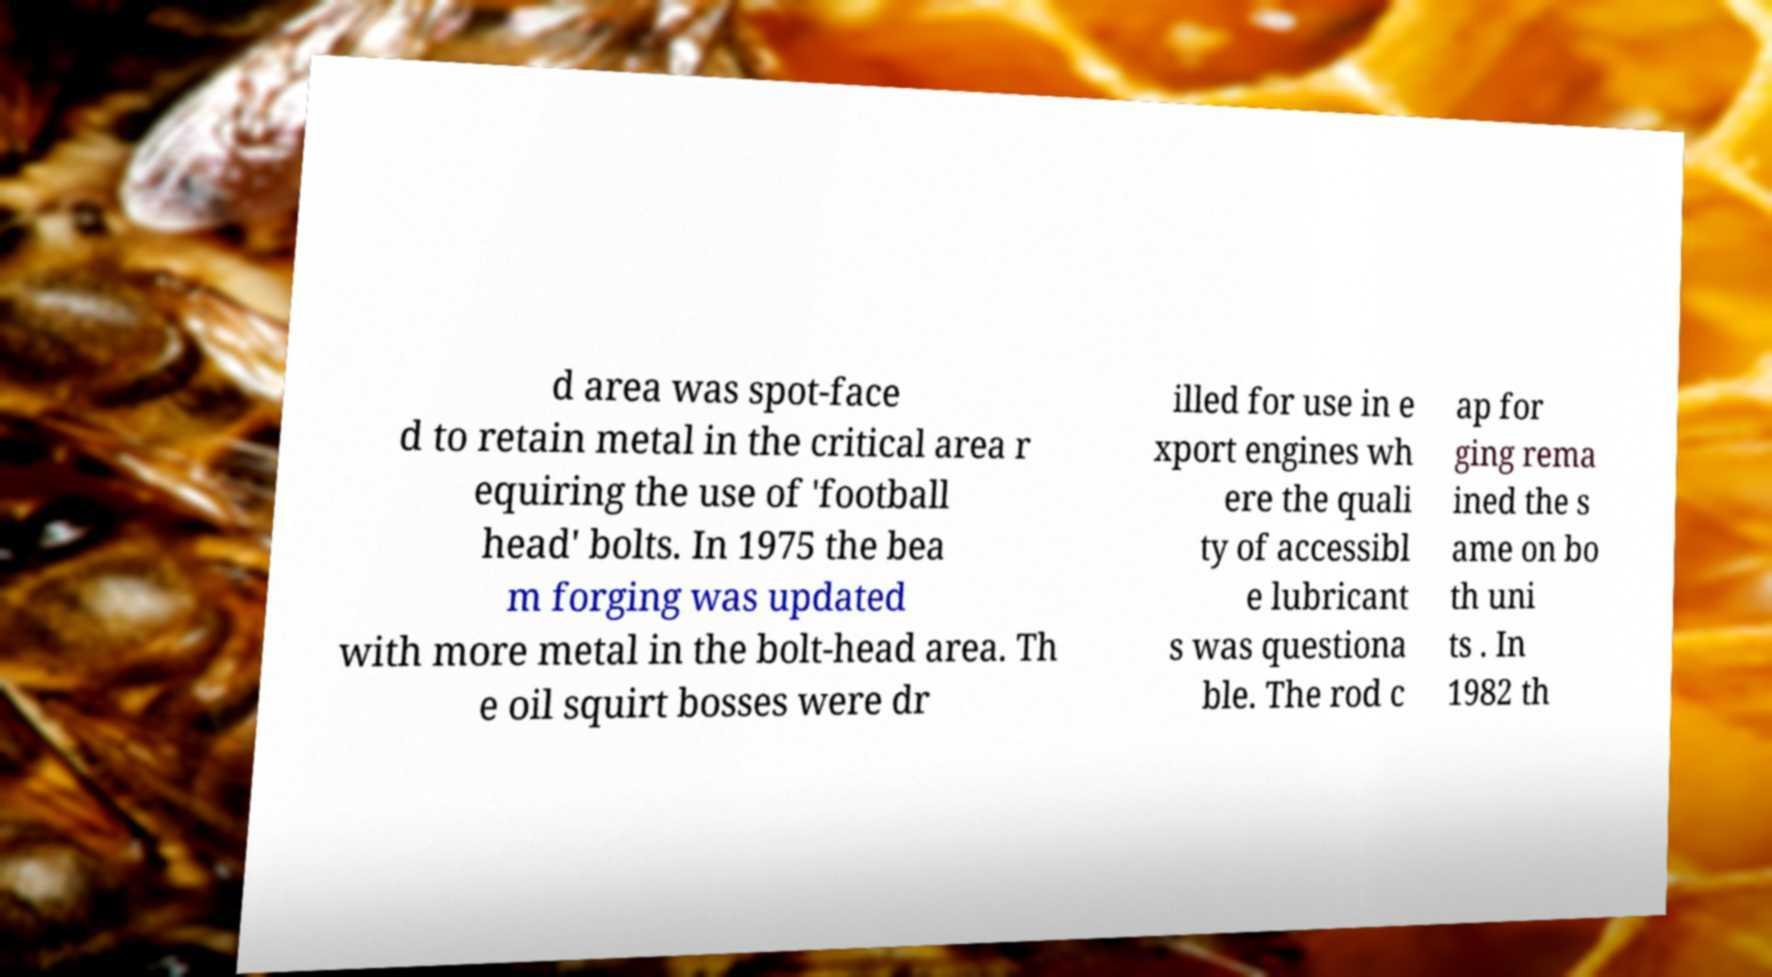Please read and relay the text visible in this image. What does it say? d area was spot-face d to retain metal in the critical area r equiring the use of 'football head' bolts. In 1975 the bea m forging was updated with more metal in the bolt-head area. Th e oil squirt bosses were dr illed for use in e xport engines wh ere the quali ty of accessibl e lubricant s was questiona ble. The rod c ap for ging rema ined the s ame on bo th uni ts . In 1982 th 